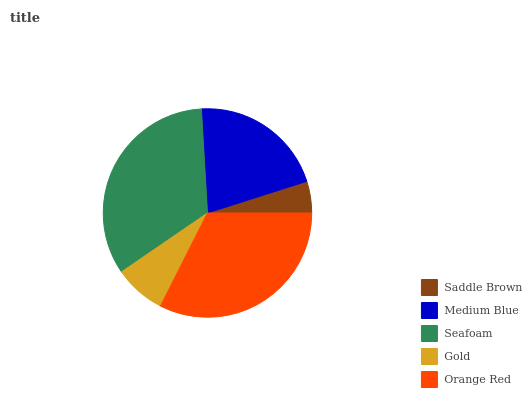Is Saddle Brown the minimum?
Answer yes or no. Yes. Is Seafoam the maximum?
Answer yes or no. Yes. Is Medium Blue the minimum?
Answer yes or no. No. Is Medium Blue the maximum?
Answer yes or no. No. Is Medium Blue greater than Saddle Brown?
Answer yes or no. Yes. Is Saddle Brown less than Medium Blue?
Answer yes or no. Yes. Is Saddle Brown greater than Medium Blue?
Answer yes or no. No. Is Medium Blue less than Saddle Brown?
Answer yes or no. No. Is Medium Blue the high median?
Answer yes or no. Yes. Is Medium Blue the low median?
Answer yes or no. Yes. Is Orange Red the high median?
Answer yes or no. No. Is Seafoam the low median?
Answer yes or no. No. 